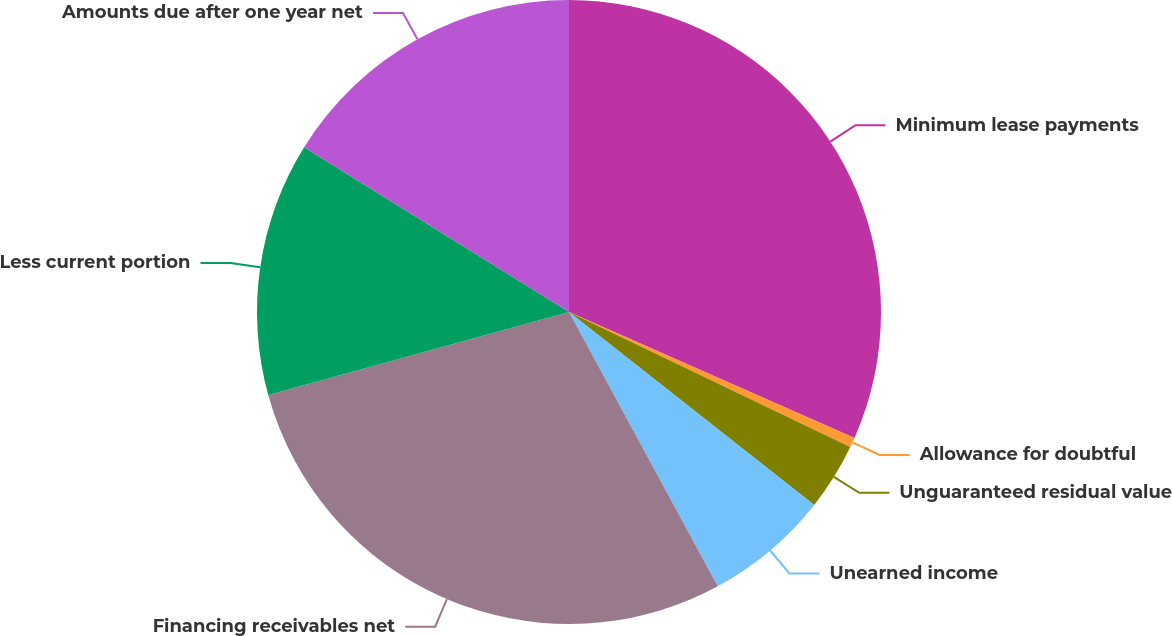<chart> <loc_0><loc_0><loc_500><loc_500><pie_chart><fcel>Minimum lease payments<fcel>Allowance for doubtful<fcel>Unguaranteed residual value<fcel>Unearned income<fcel>Financing receivables net<fcel>Less current portion<fcel>Amounts due after one year net<nl><fcel>31.61%<fcel>0.51%<fcel>3.49%<fcel>6.48%<fcel>28.62%<fcel>13.15%<fcel>16.14%<nl></chart> 